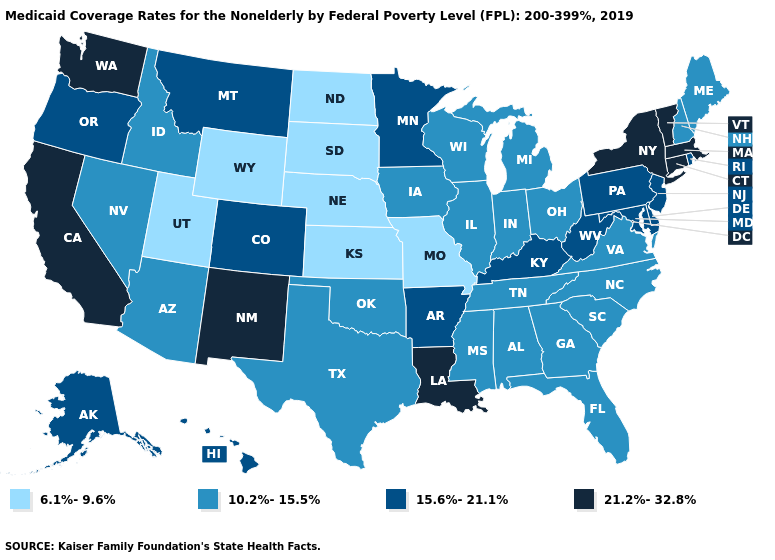Does New York have the highest value in the Northeast?
Keep it brief. Yes. Does Louisiana have the highest value in the South?
Be succinct. Yes. What is the highest value in the USA?
Keep it brief. 21.2%-32.8%. What is the value of Alaska?
Quick response, please. 15.6%-21.1%. Which states have the highest value in the USA?
Concise answer only. California, Connecticut, Louisiana, Massachusetts, New Mexico, New York, Vermont, Washington. Name the states that have a value in the range 6.1%-9.6%?
Be succinct. Kansas, Missouri, Nebraska, North Dakota, South Dakota, Utah, Wyoming. Name the states that have a value in the range 21.2%-32.8%?
Keep it brief. California, Connecticut, Louisiana, Massachusetts, New Mexico, New York, Vermont, Washington. What is the value of Kentucky?
Quick response, please. 15.6%-21.1%. Among the states that border Utah , does Wyoming have the lowest value?
Write a very short answer. Yes. What is the value of Michigan?
Answer briefly. 10.2%-15.5%. What is the value of Delaware?
Be succinct. 15.6%-21.1%. Name the states that have a value in the range 15.6%-21.1%?
Be succinct. Alaska, Arkansas, Colorado, Delaware, Hawaii, Kentucky, Maryland, Minnesota, Montana, New Jersey, Oregon, Pennsylvania, Rhode Island, West Virginia. Which states have the lowest value in the USA?
Write a very short answer. Kansas, Missouri, Nebraska, North Dakota, South Dakota, Utah, Wyoming. Among the states that border North Dakota , does Montana have the lowest value?
Quick response, please. No. How many symbols are there in the legend?
Concise answer only. 4. 